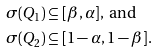<formula> <loc_0><loc_0><loc_500><loc_500>\sigma ( Q _ { 1 } ) & \subseteq [ \beta , \alpha ] , \text {     and} \\ \sigma ( Q _ { 2 } ) & \subseteq [ 1 - \alpha , 1 - \beta ] .</formula> 